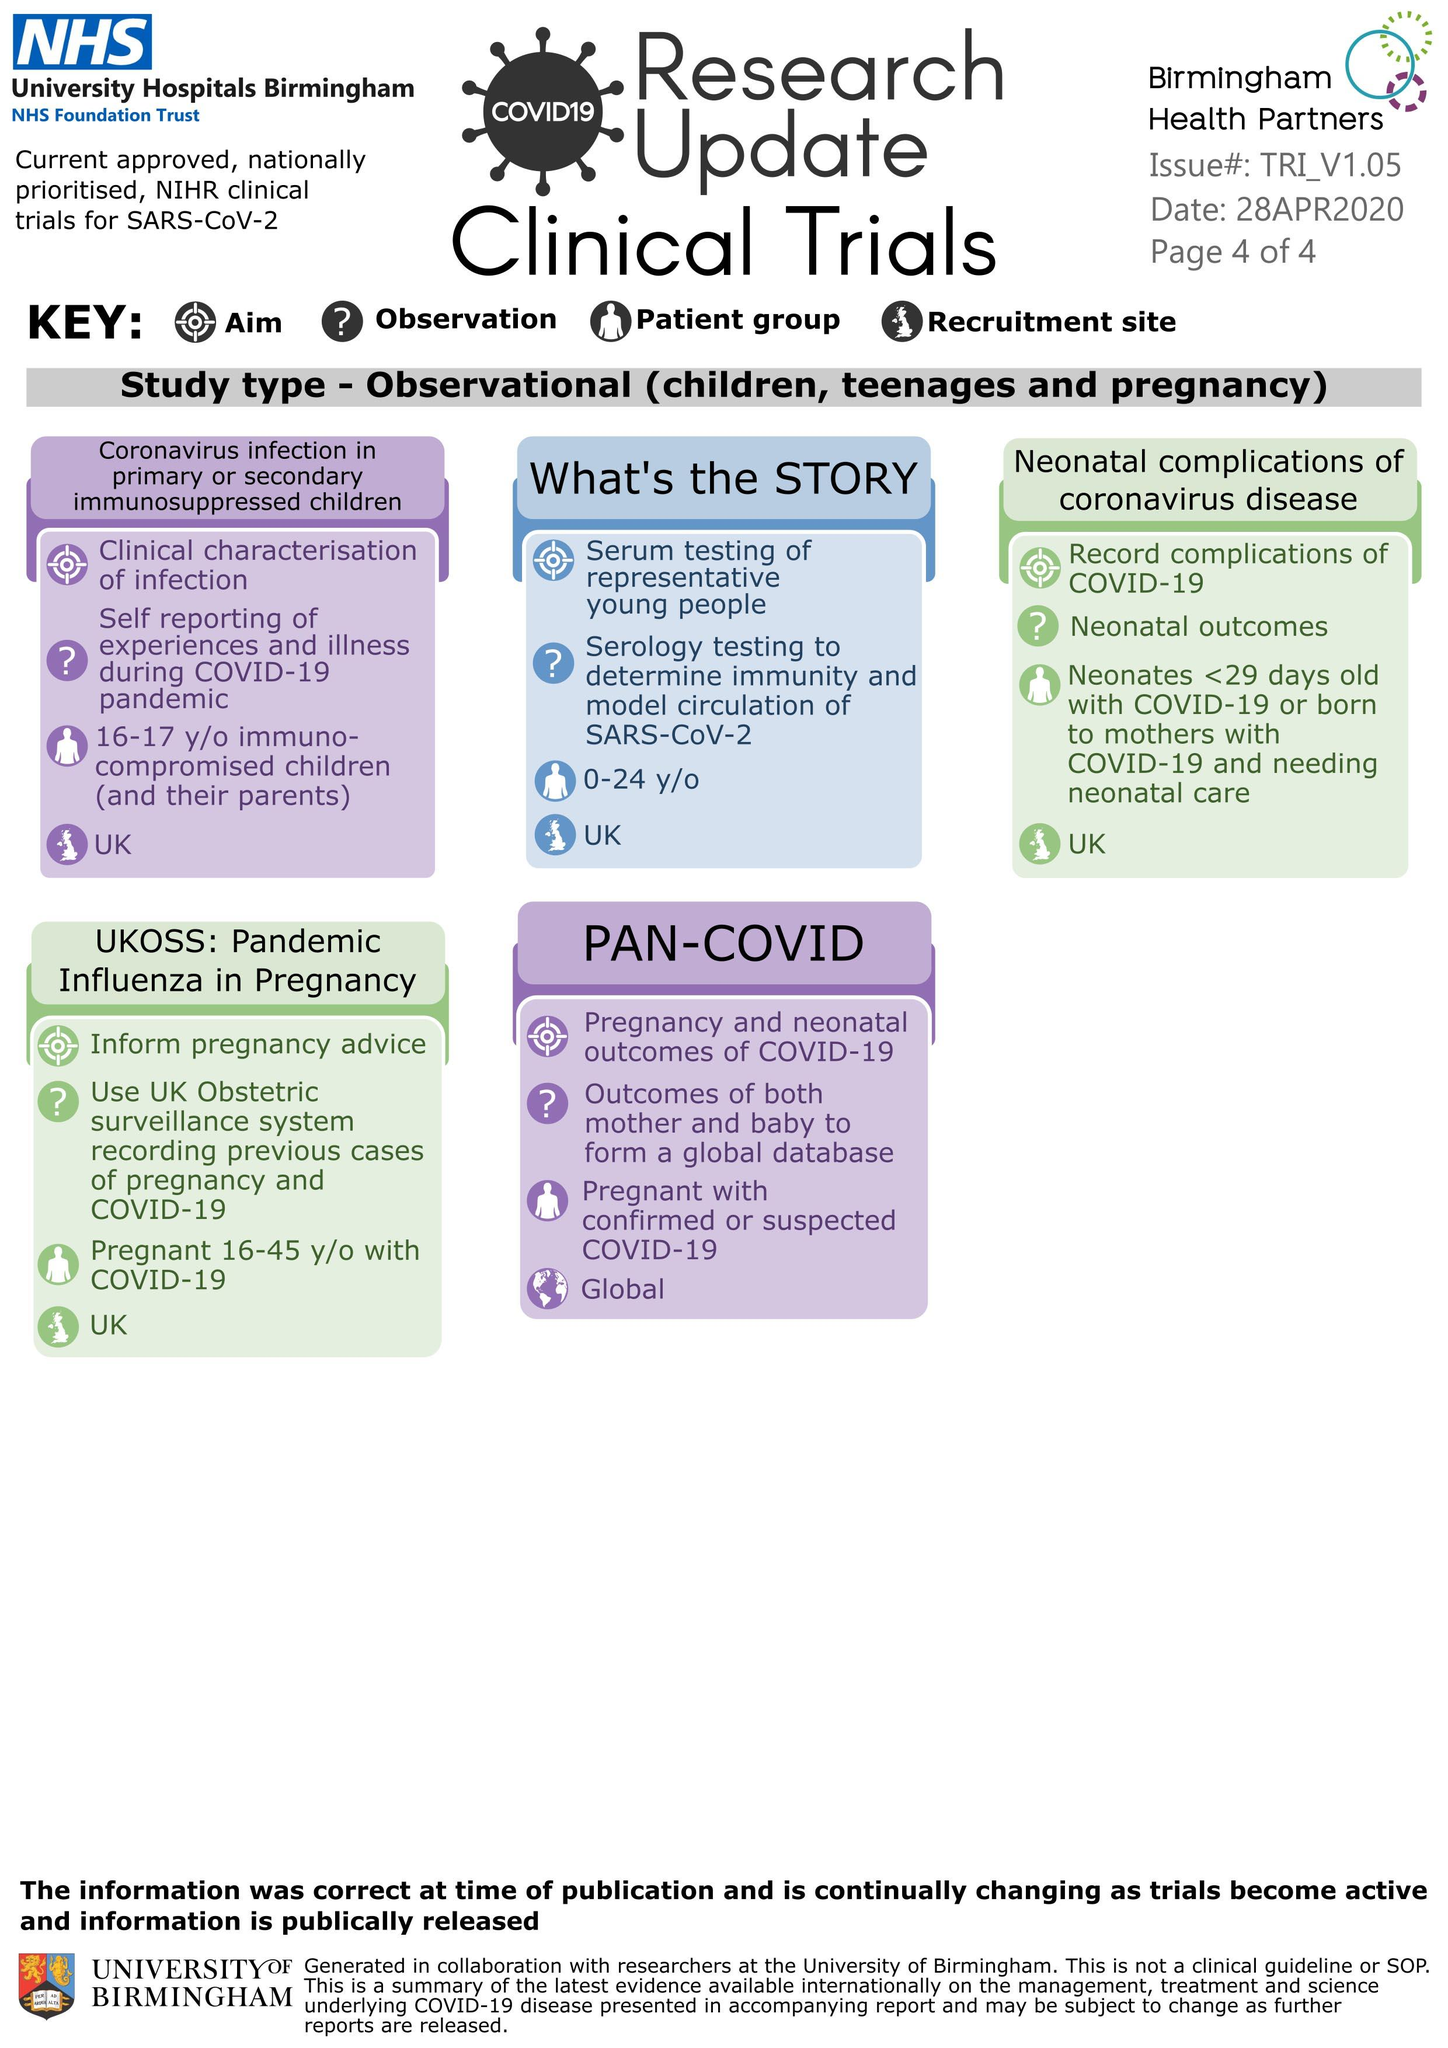Identify some key points in this picture. The aim of UKOSS: Pandemic Influenza in Pregnancy is to provide information on pregnancy advice regarding pandemic influenza. It is recorded that there are 5 clinical trials. The patient group for the clinical trial is individuals aged 0 to 24 years old. The trial in question involves a patient group of 16 to 17 year old immuno-compromised children who have been infected with the Coronavirus. The trial is focused on the primary or secondary immunosuppression of these children. What is the restriction site of the first four clinical trials mentioned in the UK? 